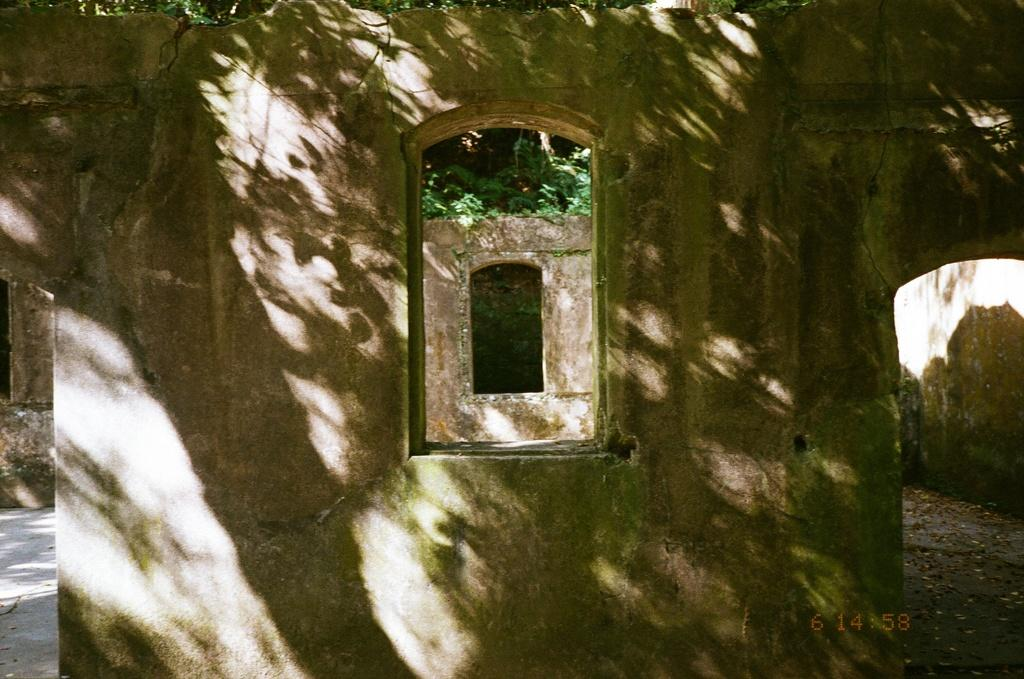What is located in the center of the image? There is a wall in the center of the image. What can be seen in the background of the image? There are trees in the background of the image. How many books can be seen on the wall in the image? There are no books visible on the wall in the image. Can you touch the trees in the background of the image? The image is a two-dimensional representation, so you cannot physically touch the trees or any other elements in the image. 